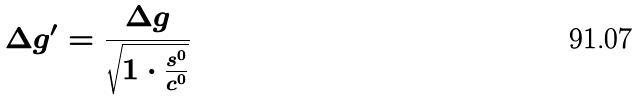Convert formula to latex. <formula><loc_0><loc_0><loc_500><loc_500>\Delta g ^ { \prime } = \frac { \Delta g } { \sqrt { 1 \cdot \frac { s ^ { 0 } } { c ^ { 0 } } } }</formula> 